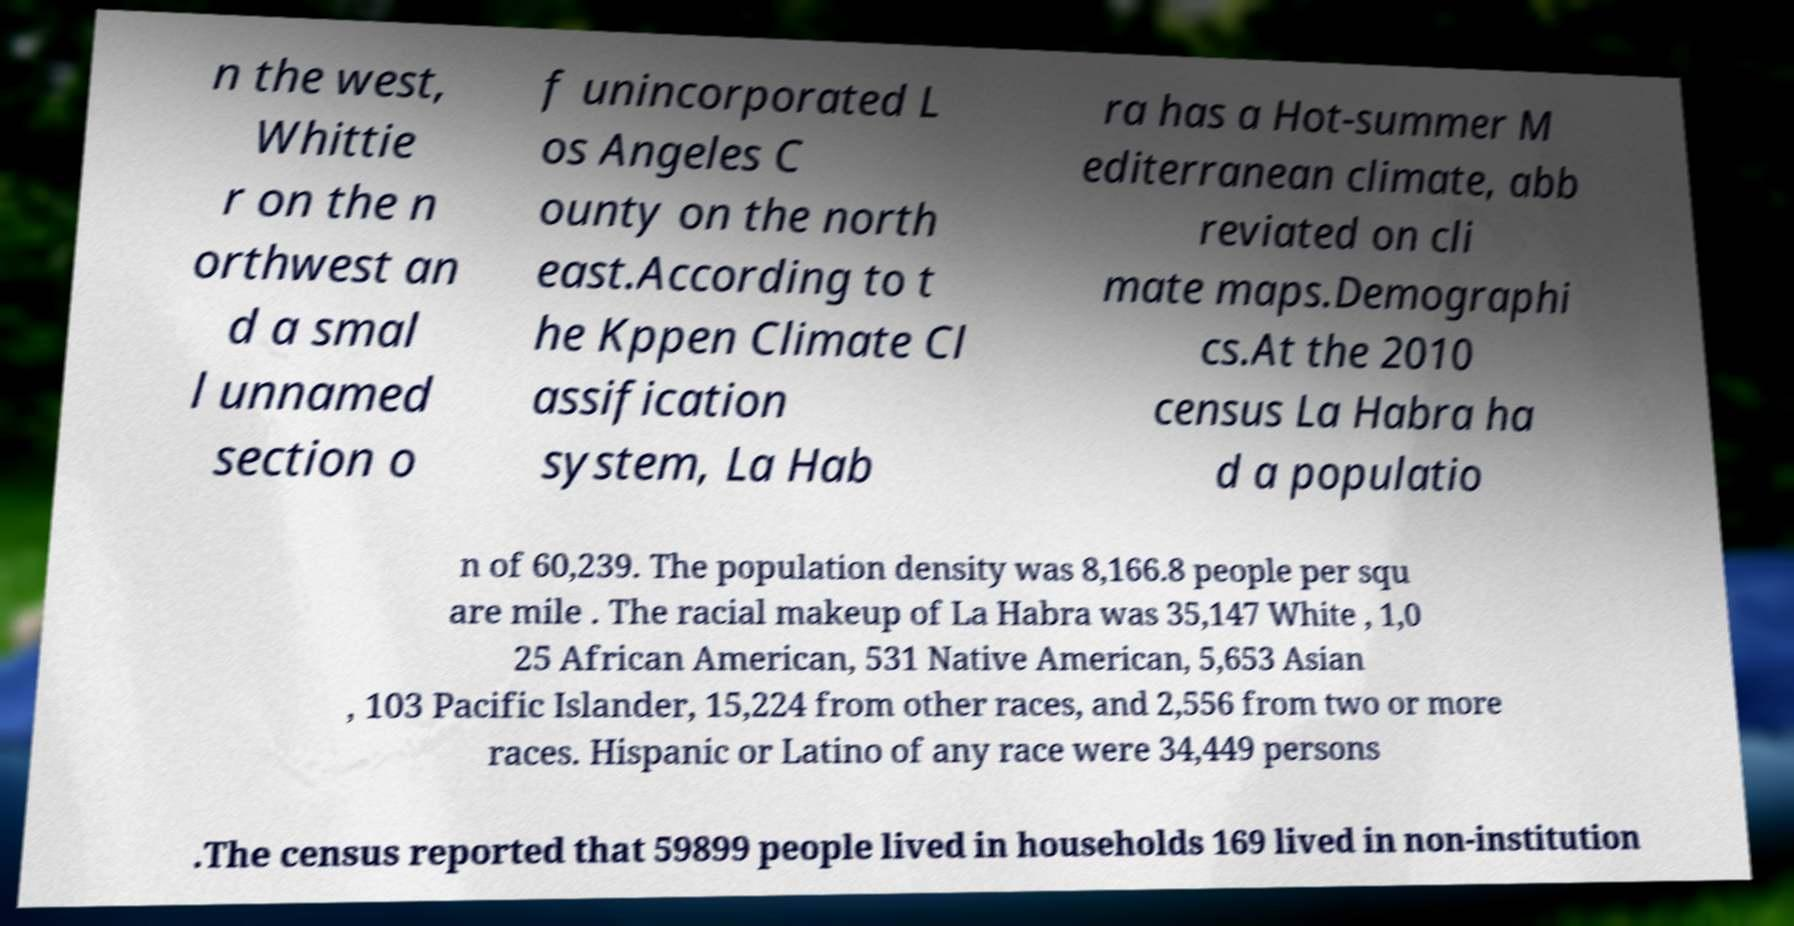Please read and relay the text visible in this image. What does it say? n the west, Whittie r on the n orthwest an d a smal l unnamed section o f unincorporated L os Angeles C ounty on the north east.According to t he Kppen Climate Cl assification system, La Hab ra has a Hot-summer M editerranean climate, abb reviated on cli mate maps.Demographi cs.At the 2010 census La Habra ha d a populatio n of 60,239. The population density was 8,166.8 people per squ are mile . The racial makeup of La Habra was 35,147 White , 1,0 25 African American, 531 Native American, 5,653 Asian , 103 Pacific Islander, 15,224 from other races, and 2,556 from two or more races. Hispanic or Latino of any race were 34,449 persons .The census reported that 59899 people lived in households 169 lived in non-institution 